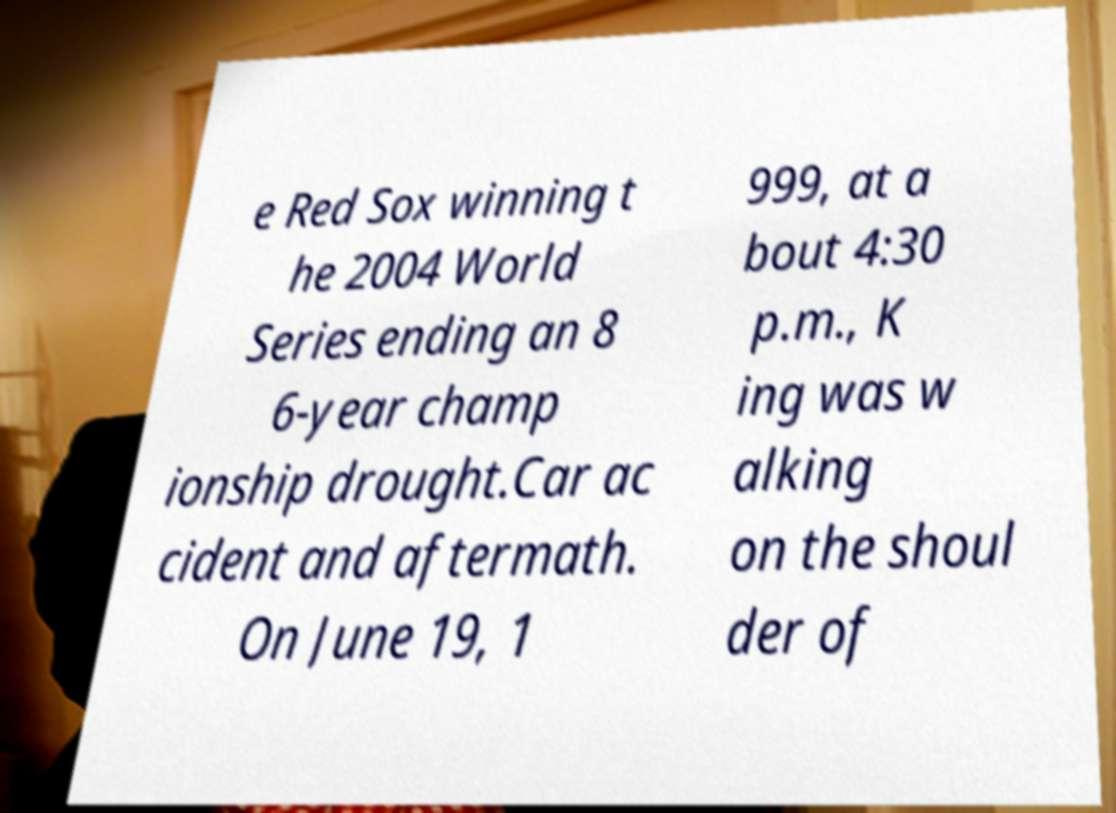Can you accurately transcribe the text from the provided image for me? e Red Sox winning t he 2004 World Series ending an 8 6-year champ ionship drought.Car ac cident and aftermath. On June 19, 1 999, at a bout 4:30 p.m., K ing was w alking on the shoul der of 